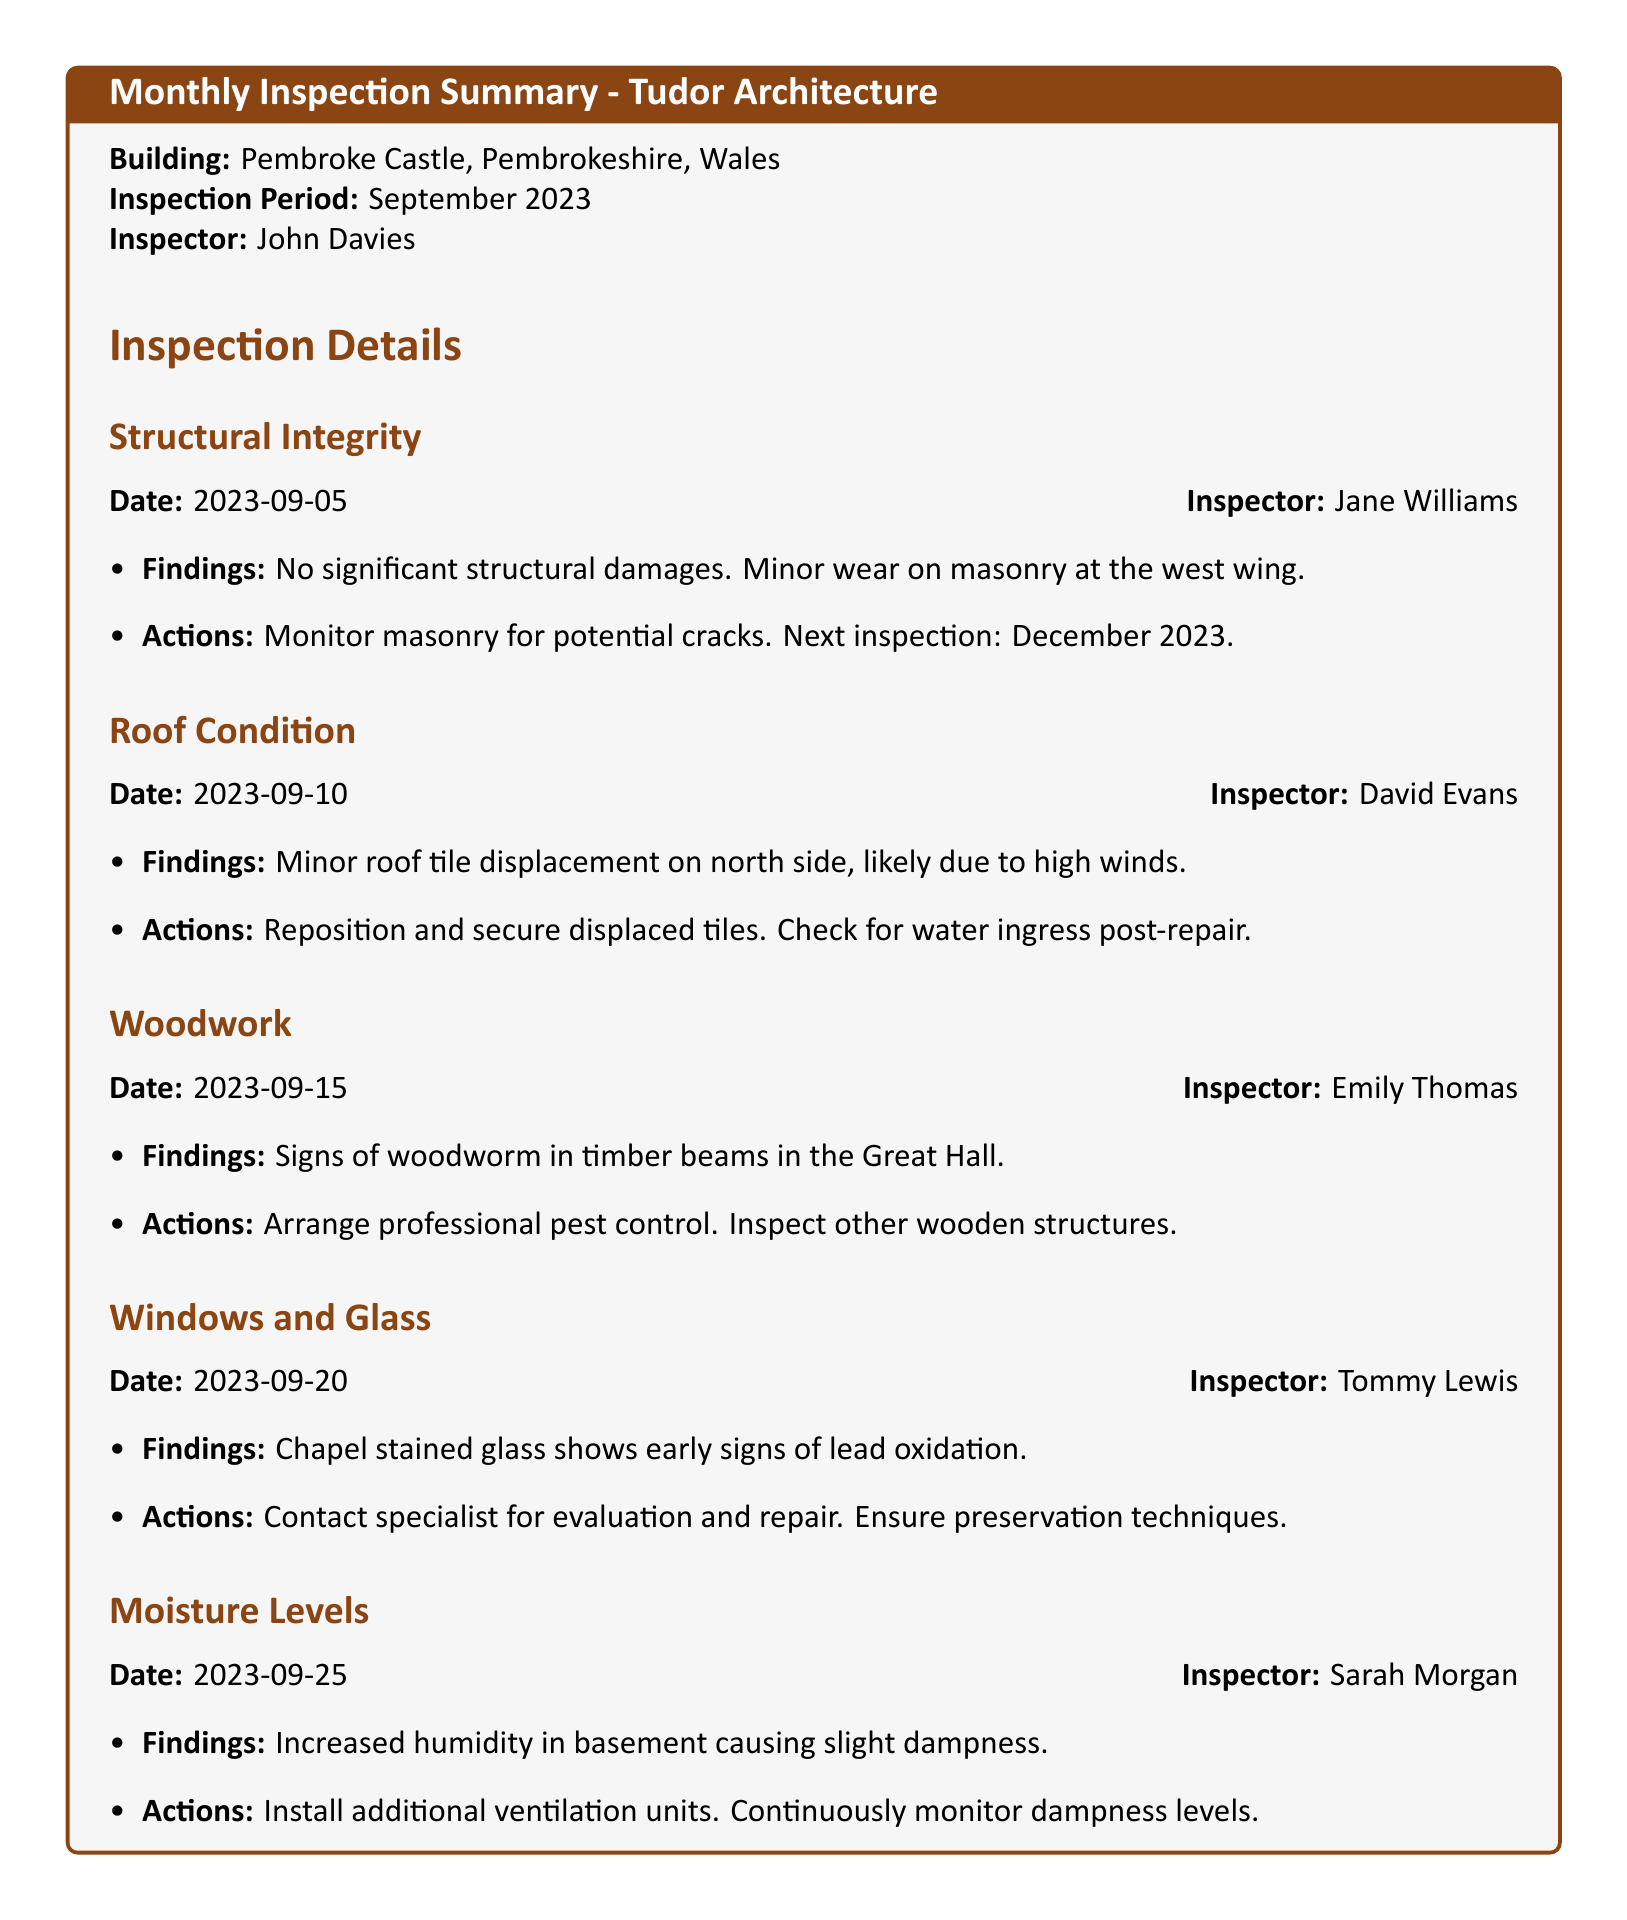what is the building inspected? The building inspected is specifically stated in the document as Pembroke Castle.
Answer: Pembroke Castle who conducted the inspection on September 5, 2023? The inspector for this date is mentioned as Jane Williams.
Answer: Jane Williams what was found during the roof inspection? The findings during the roof inspection indicate minor displacement of roof tiles.
Answer: Minor roof tile displacement when is the next inspection scheduled for masonry monitoring? The next inspection date for masonry monitoring is clearly stated to be in December 2023.
Answer: December 2023 what sign of pest was noted in the woodwork inspection? The document indicates the presence of woodworm in the timber beams.
Answer: Woodworm what action was recommended regarding the stained glass in the chapel? The action recommended was to contact a specialist for evaluation and repair.
Answer: Contact specialist for evaluation and repair how many inspectors were involved in the monthly inspection? By counting the individual inspectors mentioned in the summary, there are five inspectors documented.
Answer: Five what is causing the dampness in the basement? The document notes that increased humidity is causing the slight dampness.
Answer: Increased humidity when was the chapel stained glass inspected? The inspection date for the chapel stained glass is listed as September 20, 2023.
Answer: September 20, 2023 